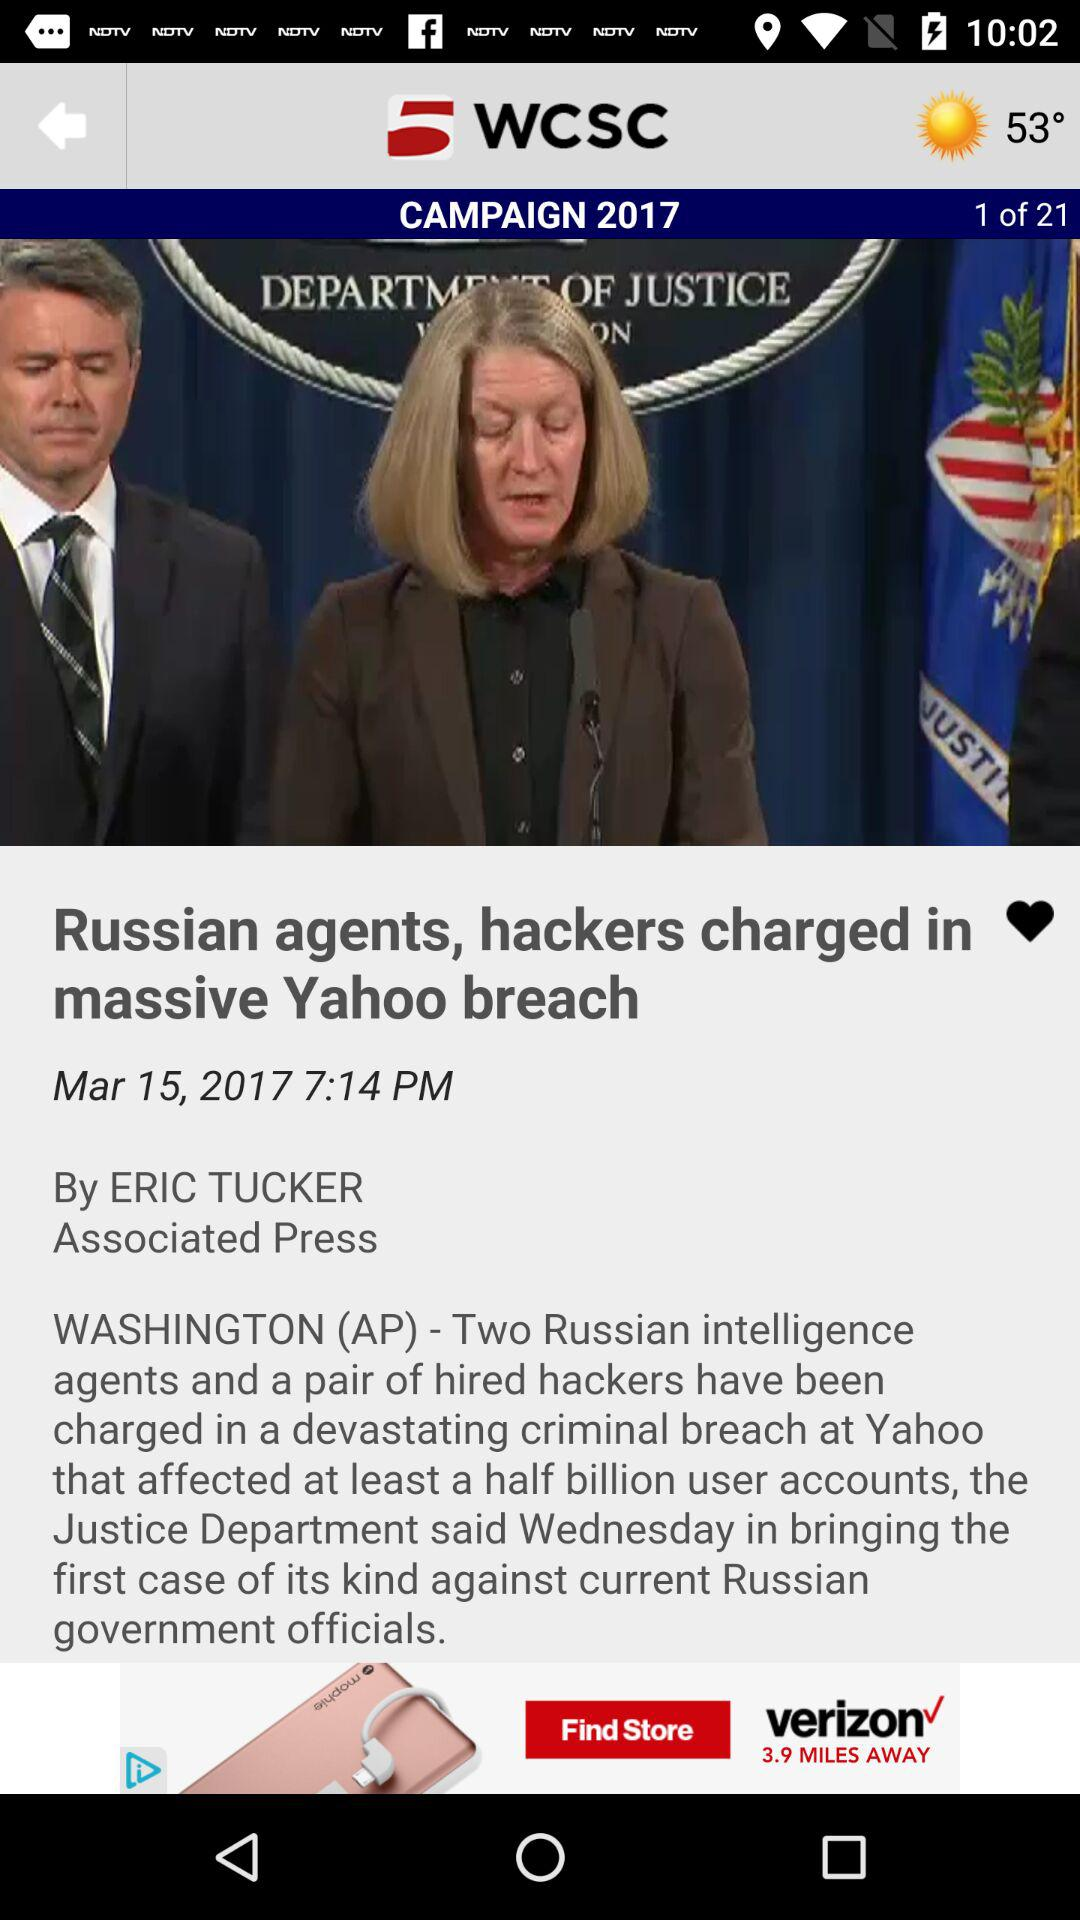At what time was the news about the "Russian agents, hackers charged in massive Yahoo breach" published? The news was updated at 7:14 PM. 